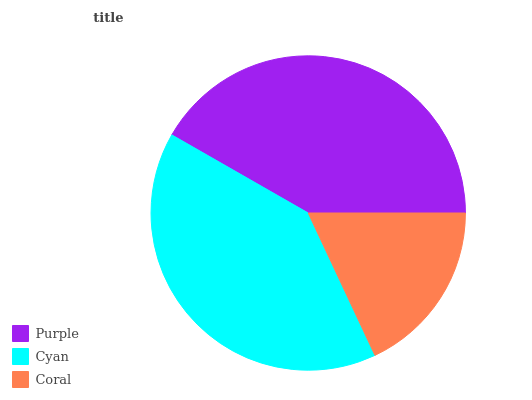Is Coral the minimum?
Answer yes or no. Yes. Is Purple the maximum?
Answer yes or no. Yes. Is Cyan the minimum?
Answer yes or no. No. Is Cyan the maximum?
Answer yes or no. No. Is Purple greater than Cyan?
Answer yes or no. Yes. Is Cyan less than Purple?
Answer yes or no. Yes. Is Cyan greater than Purple?
Answer yes or no. No. Is Purple less than Cyan?
Answer yes or no. No. Is Cyan the high median?
Answer yes or no. Yes. Is Cyan the low median?
Answer yes or no. Yes. Is Purple the high median?
Answer yes or no. No. Is Coral the low median?
Answer yes or no. No. 